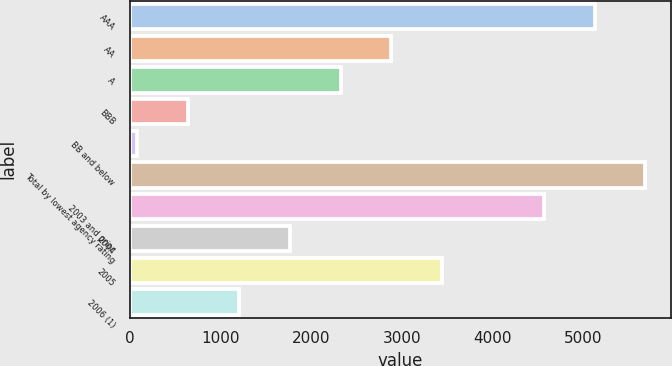Convert chart. <chart><loc_0><loc_0><loc_500><loc_500><bar_chart><fcel>AAA<fcel>AA<fcel>A<fcel>BBB<fcel>BB and below<fcel>Total by lowest agency rating<fcel>2003 and prior<fcel>2004<fcel>2005<fcel>2006 (1)<nl><fcel>5125.37<fcel>2885.65<fcel>2325.72<fcel>645.93<fcel>86<fcel>5685.3<fcel>4565.44<fcel>1765.79<fcel>3445.58<fcel>1205.86<nl></chart> 